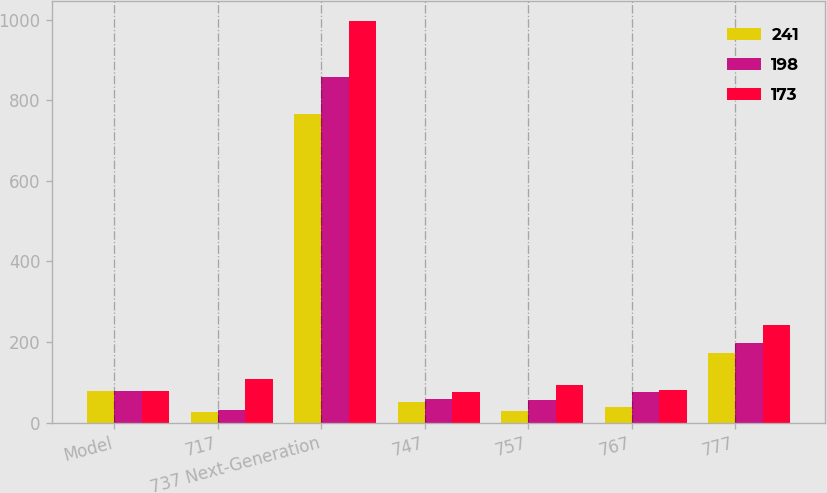Convert chart. <chart><loc_0><loc_0><loc_500><loc_500><stacked_bar_chart><ecel><fcel>Model<fcel>717<fcel>737 Next-Generation<fcel>747<fcel>757<fcel>767<fcel>777<nl><fcel>241<fcel>79.5<fcel>26<fcel>765<fcel>52<fcel>28<fcel>39<fcel>173<nl><fcel>198<fcel>79.5<fcel>30<fcel>857<fcel>59<fcel>55<fcel>77<fcel>198<nl><fcel>173<fcel>79.5<fcel>107<fcel>997<fcel>77<fcel>94<fcel>82<fcel>241<nl></chart> 